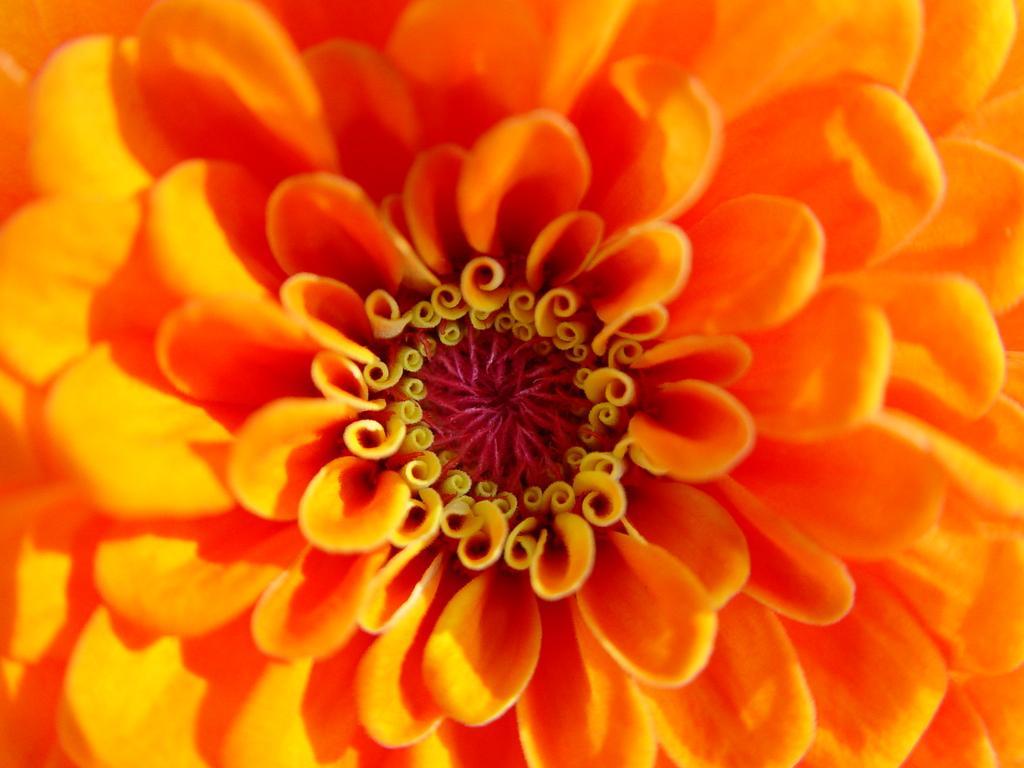Please provide a concise description of this image. In this picture, we can see a flower. 